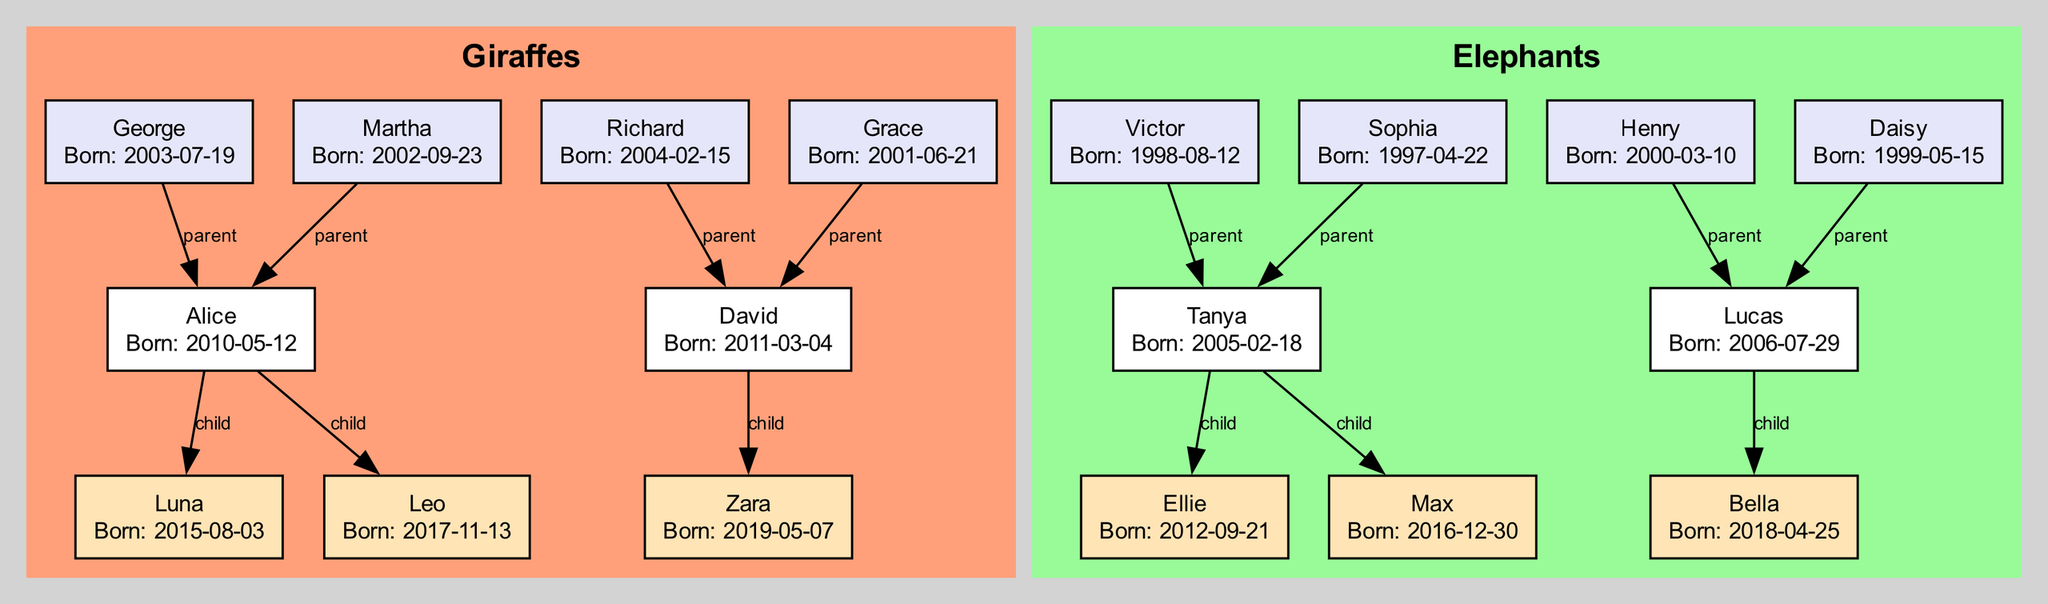What is the name of Alice's mother? To find Alice's mother, I look at her node in the diagram. Alice's parents are listed, and among them, I identify Martha, who is specified as a parent.
Answer: Martha How many offspring does Tanya have? In the elephant section of the diagram, I locate Tanya's node and then check her offspring list. It reveals that Tanya has two offspring: Ellie and Max.
Answer: 2 Who are the parents of David? To answer, I find the node for David in the diagram. From David's node, I can see that his parents are Richard and Grace.
Answer: Richard and Grace Which animal has the earliest birth date? I compare the birth dates of all animals listed in the diagram. Victor, who is Tanya's father, was born on August 12, 1998, which is earlier than all the other animals' birth dates.
Answer: Victor How many total nodes are there in the giraffe subtree? Focusing on the giraffe section, I count the nodes including Alice, her parents (George and Martha), and her offspring (Luna and Leo). This totals five nodes in the giraffe section.
Answer: 5 What is the relationship between Luna and Alice? To answer this, I trace the connection from Luna's node back to Alice's node. Luna is listed as an offspring of Alice, indicating that Alice is her parent.
Answer: Parent What is the birth date of Ellie's father? To find out Ellie's father's birth date, I find the node for Tanya and then look at her offspring. Ellie is listed, and I go back to Tanya's node to find her father, Victor, who was born on August 12, 1998.
Answer: 1998-08-12 Which species does David belong to? I find David's node in the diagram and observe that it is located within the Giraffes section, which confirms his species.
Answer: Giraffe How many distinct parental pairs are represented in the diagram? I examine the parents for all animals in the diagram. Each animal has two parents, and by counting them, I find there are four parental pairs: George and Martha, Richard and Grace, Victor and Sophia, and Henry and Daisy.
Answer: 4 